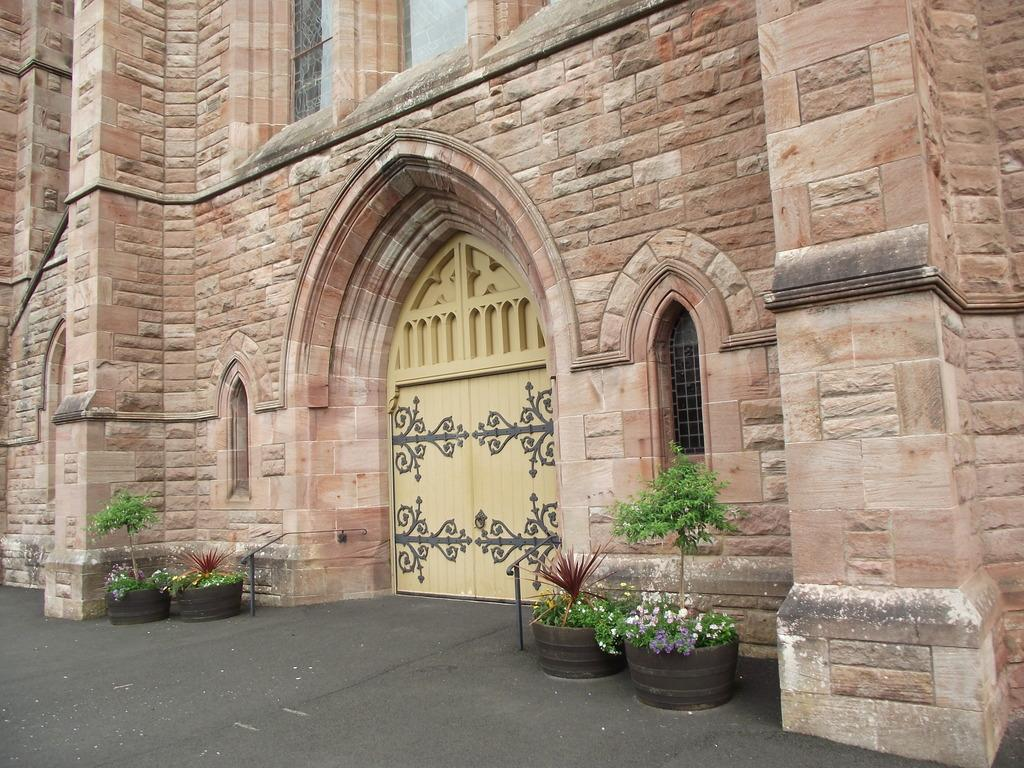What type of structure is visible in the image? There is a building in the image. What part of the building can be seen in the image? There is a window and a door visible in the image. What is located near the building? There is a plant pot and a road in the image. What type of health advice can be seen on the wall in the image? There is no wall present in the image, so it is not possible to determine if any health advice is visible. 